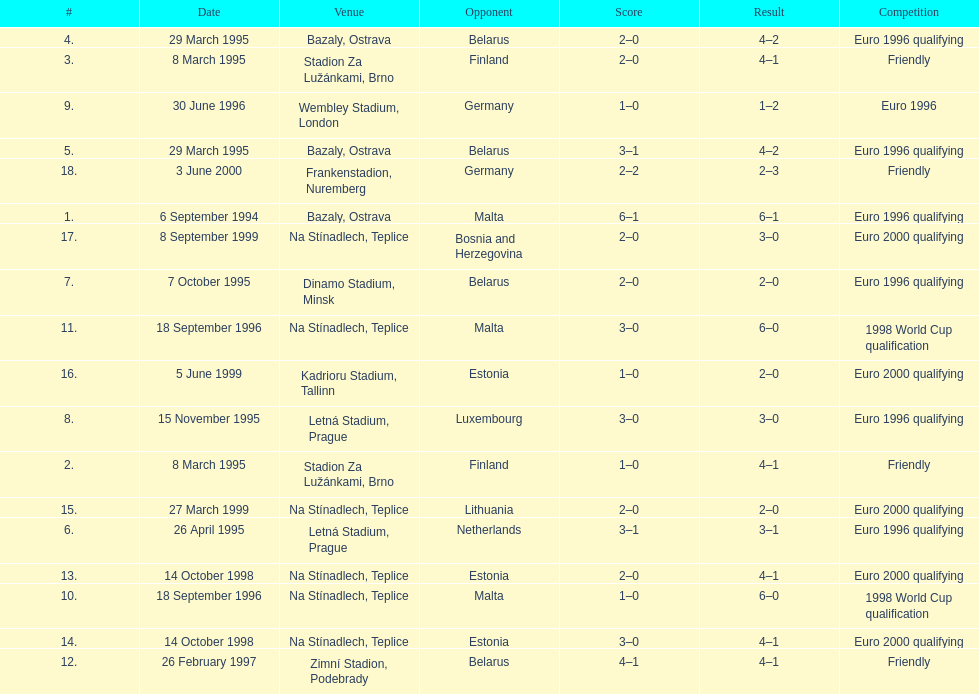How many total games took place in 1999? 3. 